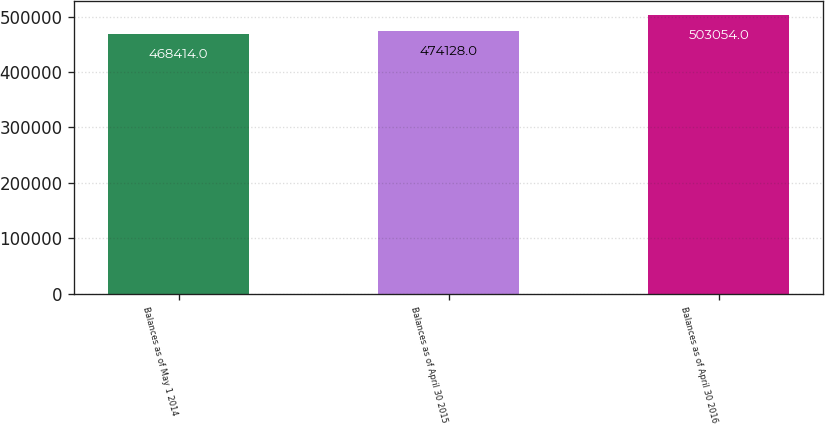Convert chart to OTSL. <chart><loc_0><loc_0><loc_500><loc_500><bar_chart><fcel>Balances as of May 1 2014<fcel>Balances as of April 30 2015<fcel>Balances as of April 30 2016<nl><fcel>468414<fcel>474128<fcel>503054<nl></chart> 